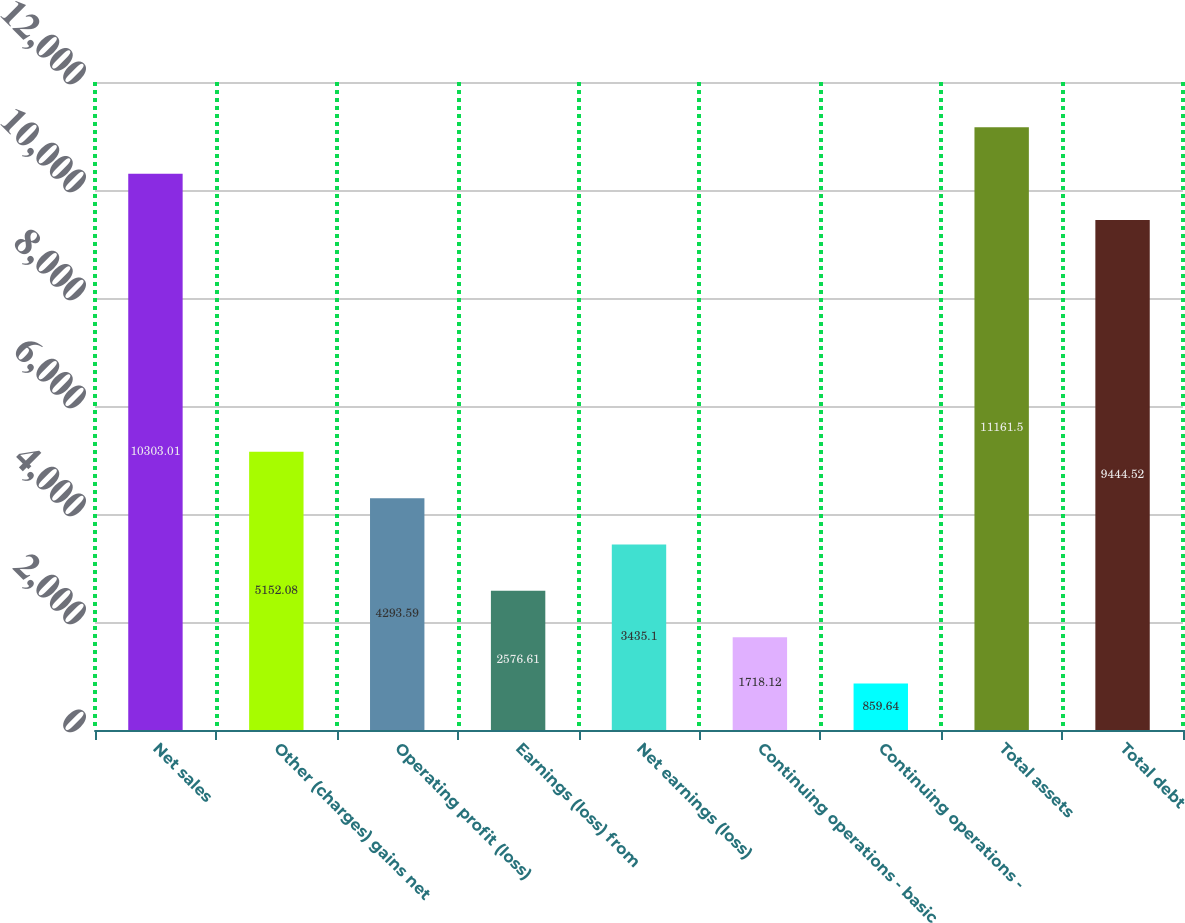Convert chart to OTSL. <chart><loc_0><loc_0><loc_500><loc_500><bar_chart><fcel>Net sales<fcel>Other (charges) gains net<fcel>Operating profit (loss)<fcel>Earnings (loss) from<fcel>Net earnings (loss)<fcel>Continuing operations - basic<fcel>Continuing operations -<fcel>Total assets<fcel>Total debt<nl><fcel>10303<fcel>5152.08<fcel>4293.59<fcel>2576.61<fcel>3435.1<fcel>1718.12<fcel>859.64<fcel>11161.5<fcel>9444.52<nl></chart> 